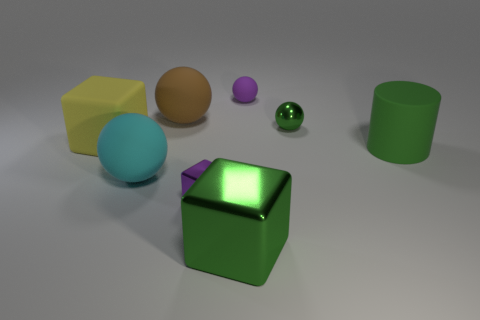Add 1 large gray spheres. How many objects exist? 9 Subtract all metal balls. How many balls are left? 3 Subtract all green cubes. How many cubes are left? 2 Subtract all cylinders. How many objects are left? 7 Subtract 1 blocks. How many blocks are left? 2 Add 7 purple matte objects. How many purple matte objects are left? 8 Add 3 green rubber cubes. How many green rubber cubes exist? 3 Subtract 0 gray balls. How many objects are left? 8 Subtract all yellow blocks. Subtract all gray balls. How many blocks are left? 2 Subtract all green balls. How many yellow cubes are left? 1 